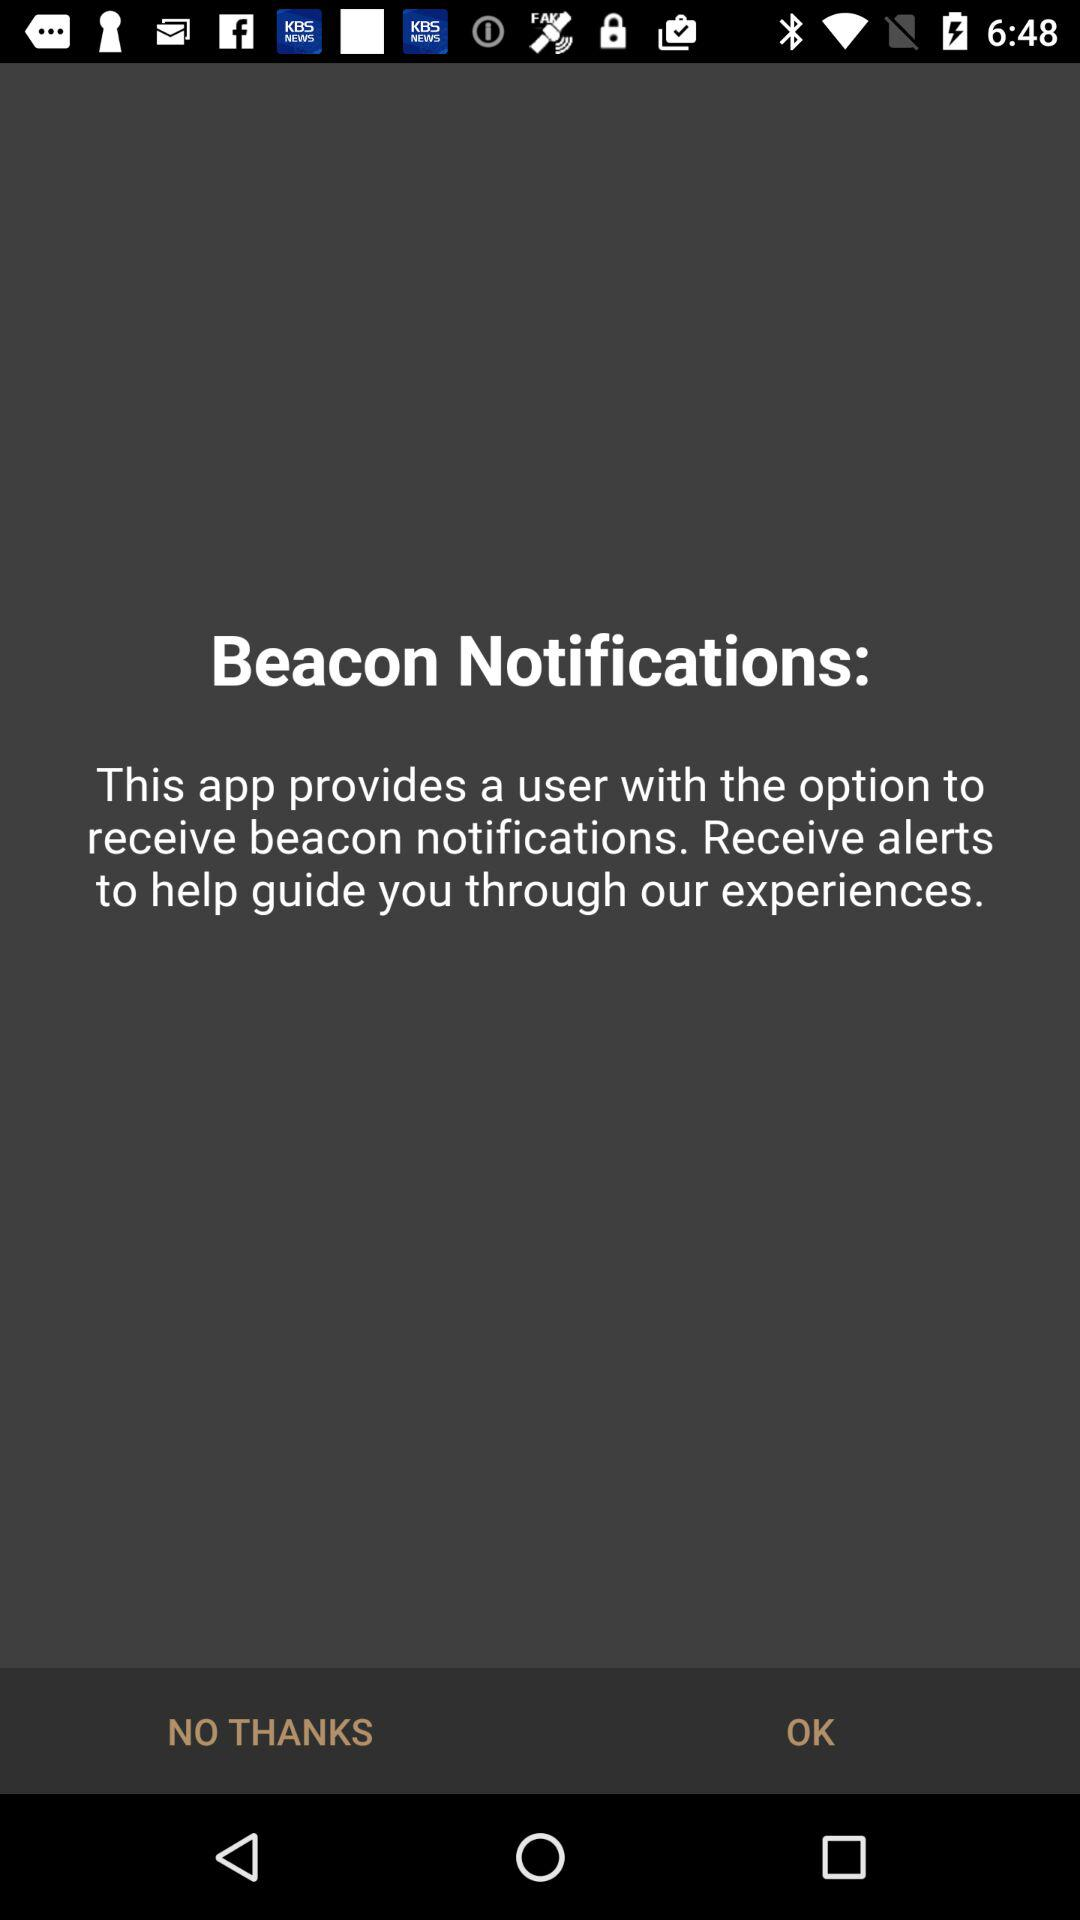What does the app provide? The app provides a user with the option to receive beacon notifications. 